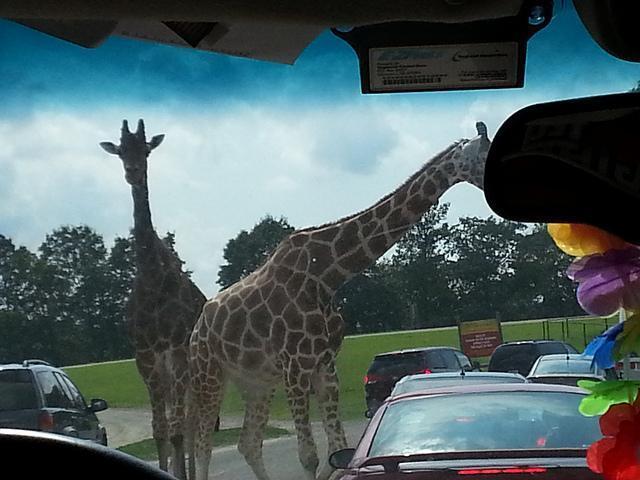How many giraffes are there?
Give a very brief answer. 2. How many giraffes can you see?
Give a very brief answer. 2. How many cars are in the photo?
Give a very brief answer. 4. 